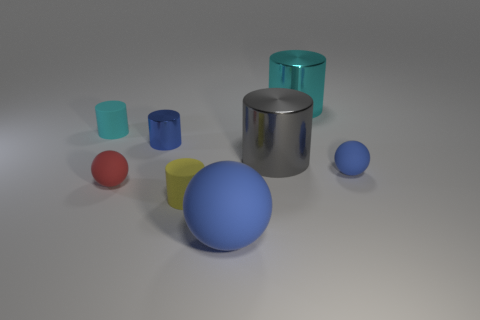Subtract all big blue balls. How many balls are left? 2 Subtract all yellow cylinders. How many cylinders are left? 4 Add 2 tiny blue metal things. How many objects exist? 10 Subtract 2 balls. How many balls are left? 1 Subtract all large blue matte spheres. Subtract all small red balls. How many objects are left? 6 Add 8 big cyan things. How many big cyan things are left? 9 Add 4 blue things. How many blue things exist? 7 Subtract 0 red cubes. How many objects are left? 8 Subtract all balls. How many objects are left? 5 Subtract all green balls. Subtract all blue cubes. How many balls are left? 3 